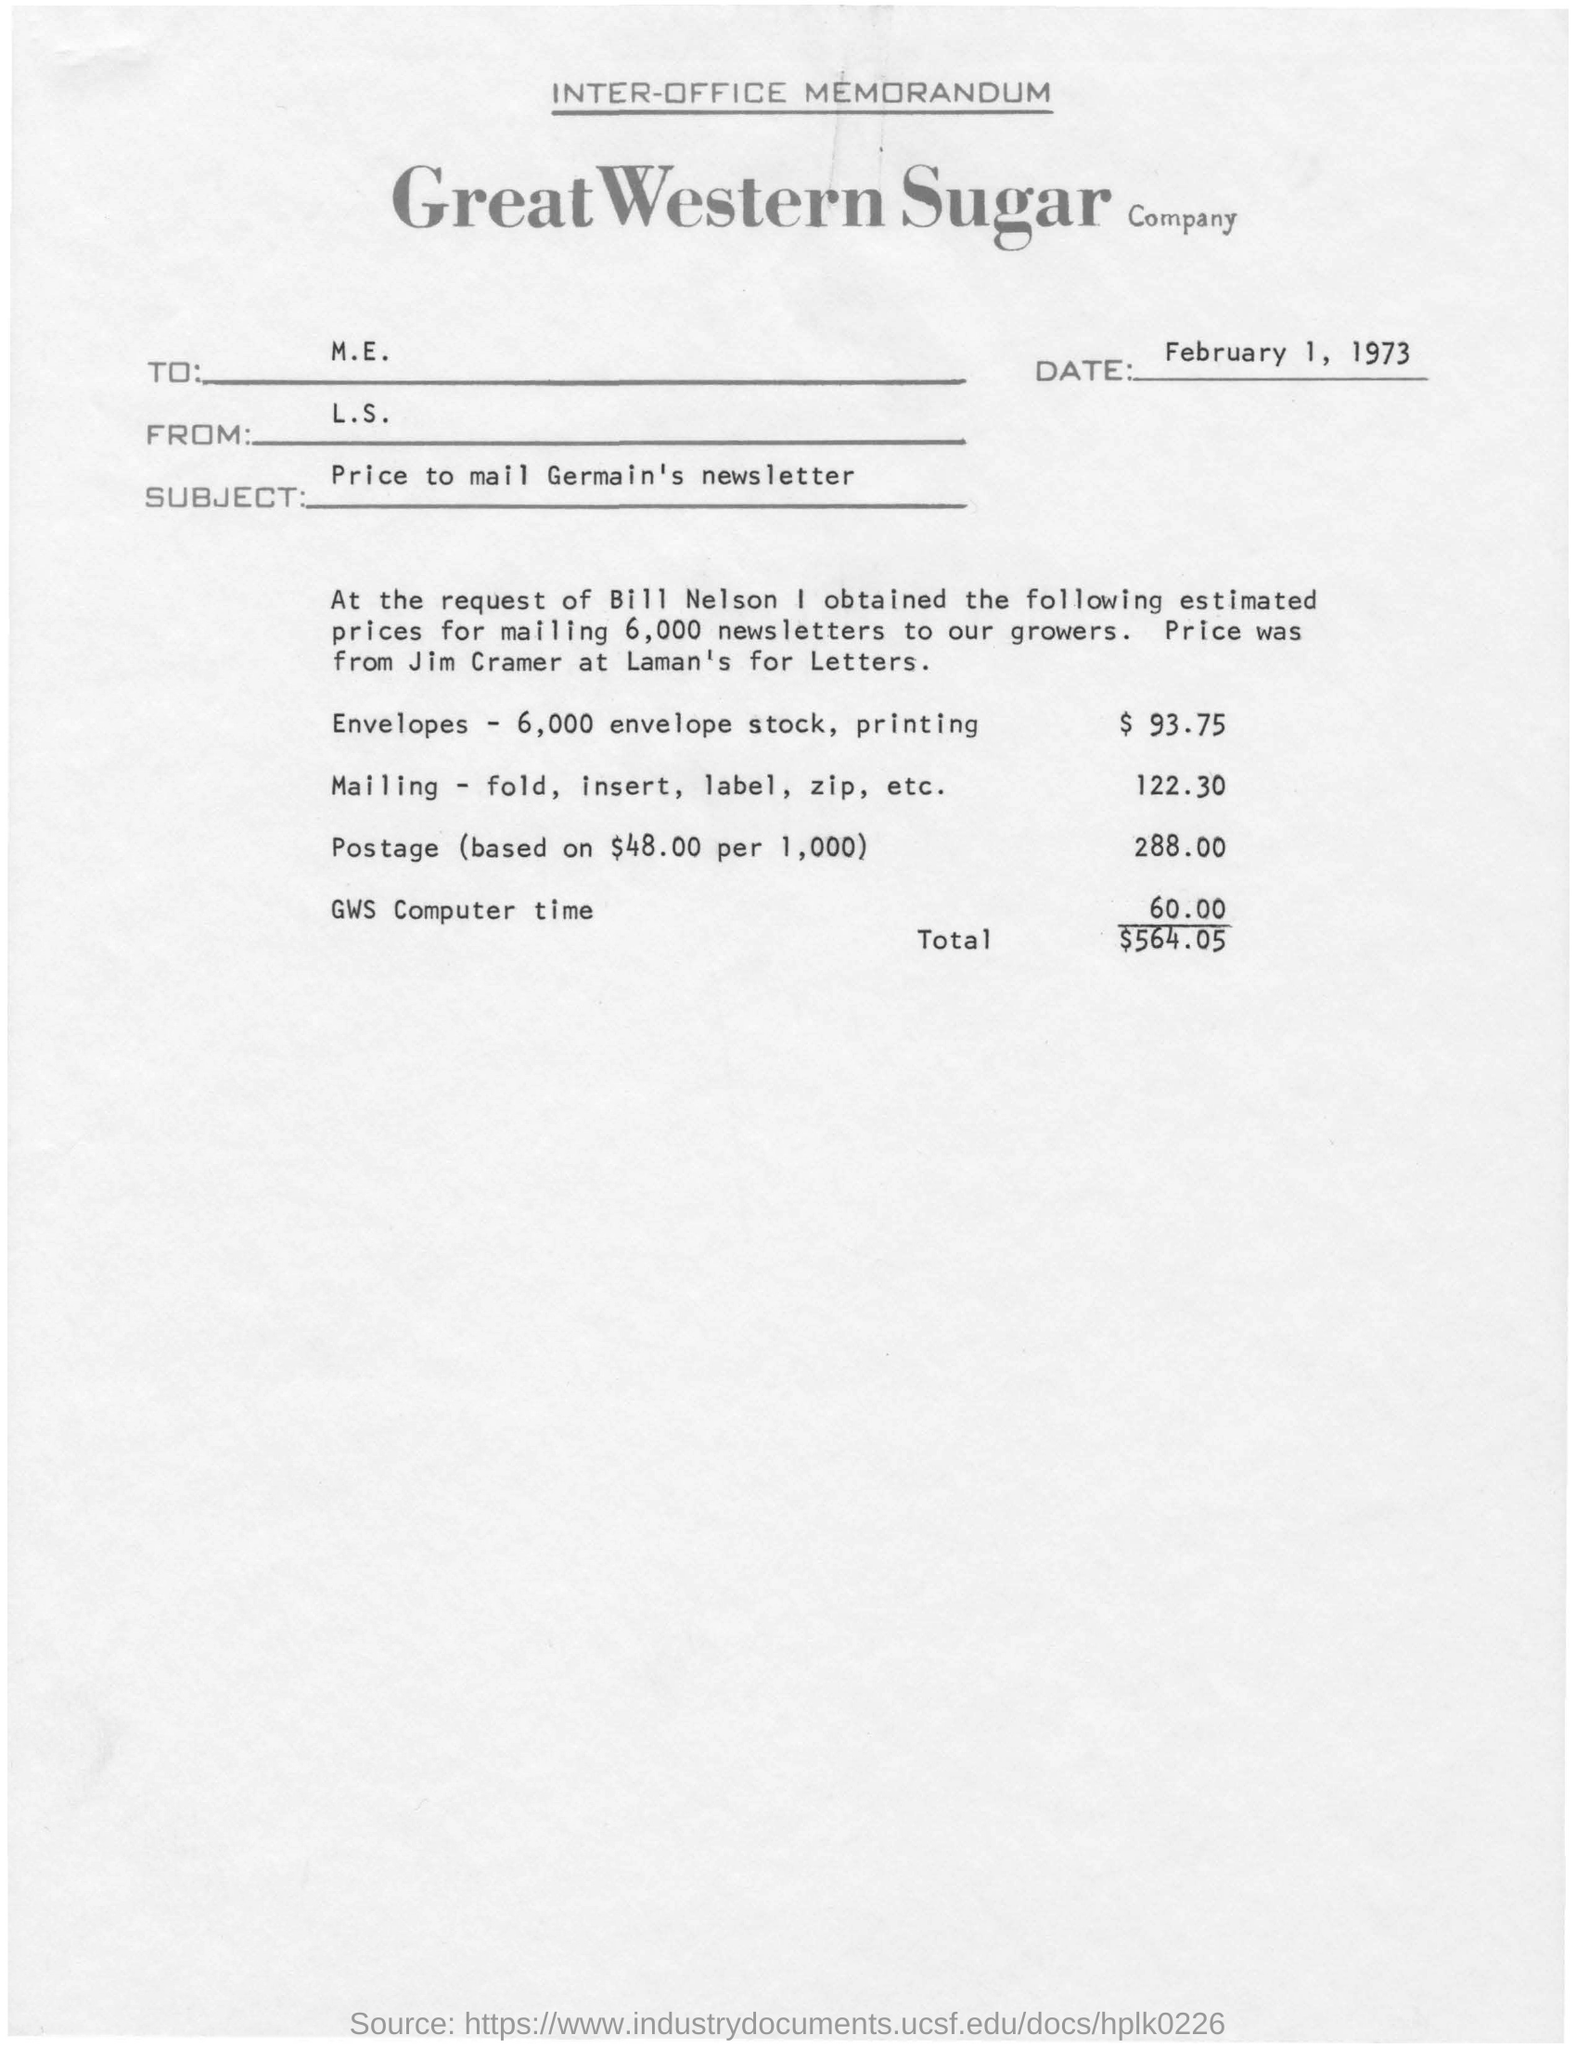What is the subject mentioned in the memorandum?
Keep it short and to the point. Price to mail Germain's newsletter. What is the "total" listed?
Give a very brief answer. $564.05. What is the date in the memorandum?
Keep it short and to the point. February 1, 1973. 